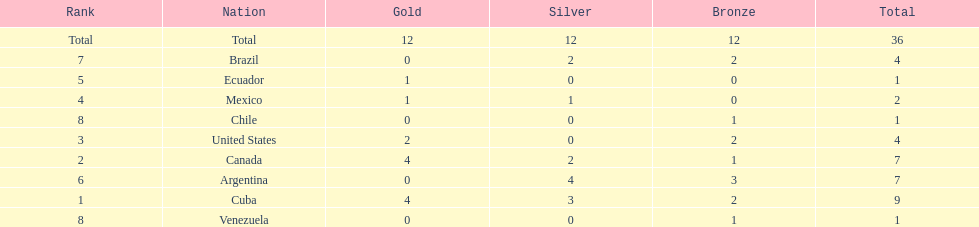What is the total number of nations that did not win gold? 4. 